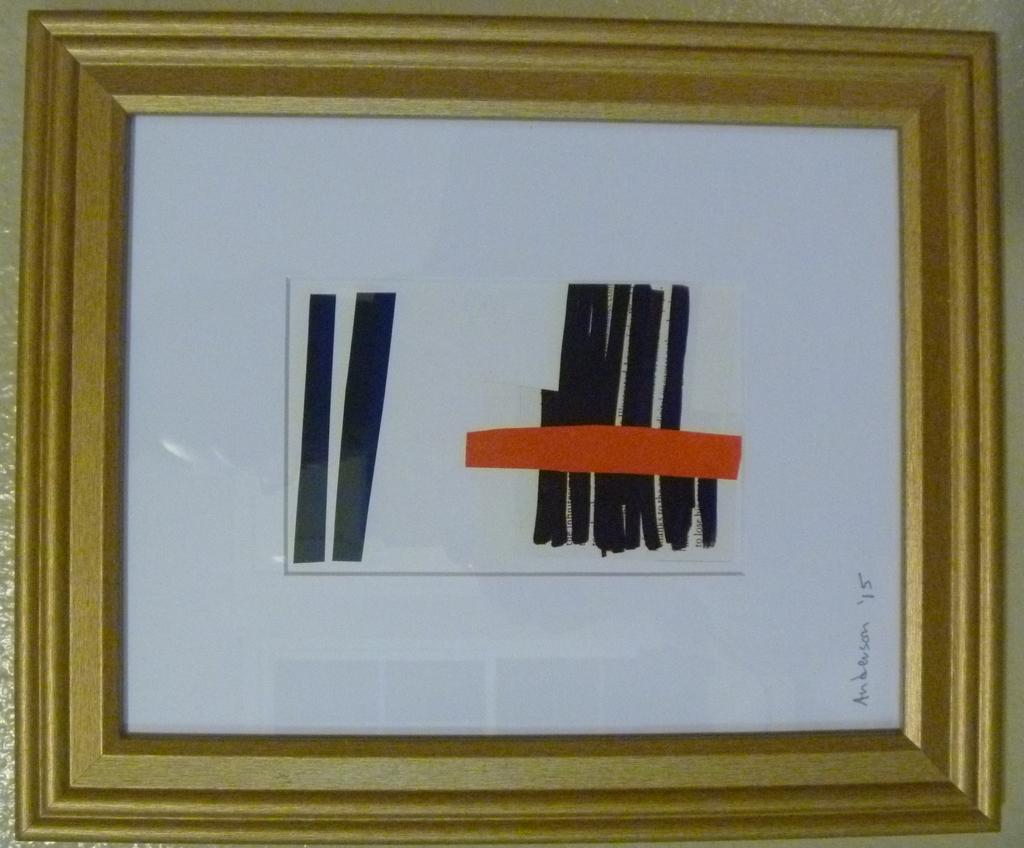What object can be seen in the image that typically holds a photograph? There is a photo frame in the image. What is the color of the photo frame? The photo frame has a white color. Are there any lines visible in the photo frame? Yes, there are black lines and a red line in the photo frame. What type of apparel is the person wearing in the photo frame? There is no person visible in the image, as it only shows a photo frame with lines. 